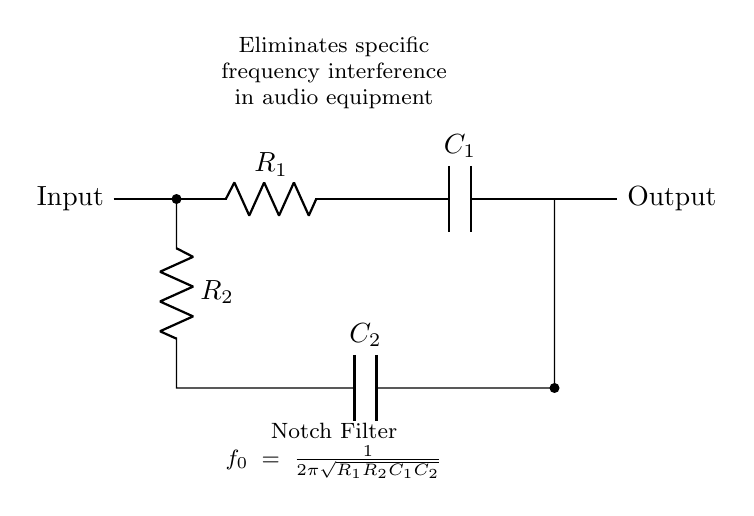What type of filter is this circuit? The circuit is labeled as a notch filter, which indicates its function to eliminate specific frequency interference.
Answer: notch filter What components are present in the circuit? The circuit contains two resistors (R1 and R2) and two capacitors (C1 and C2) as indicated by the labels in the diagram.
Answer: resistors and capacitors What is the role of the component labeled R1? R1 is a resistor in the signal path which influences the impedance of the circuit and helps determine the notch frequency.
Answer: resistance How is the notch frequency calculated? The formula provided in the circuit shows that the notch frequency is calculated using the formula f0 = 1/(2π√(R1R2C1C2)). This requires knowing the values of both resistors and capacitors in the circuit.
Answer: f0 = 1/(2π√(R1R2C1C2)) What happens to the output at the notch frequency? At the notch frequency, the output is significantly reduced due to the interference cancellation effect of the filter, effectively minimizing that specific frequency in the output signal.
Answer: output reduced How does this circuit improve audio quality? By eliminating specific frequency interferences, which may cause unwanted noise or distortion in audio equipment, this circuit helps enhance the clarity and overall quality of the sound output.
Answer: improves clarity 